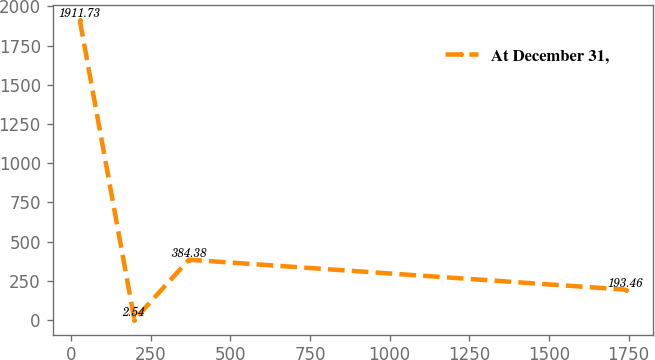Convert chart to OTSL. <chart><loc_0><loc_0><loc_500><loc_500><line_chart><ecel><fcel>At December 31,<nl><fcel>27.14<fcel>1911.73<nl><fcel>198.47<fcel>2.54<nl><fcel>369.8<fcel>384.38<nl><fcel>1740.44<fcel>193.46<nl></chart> 